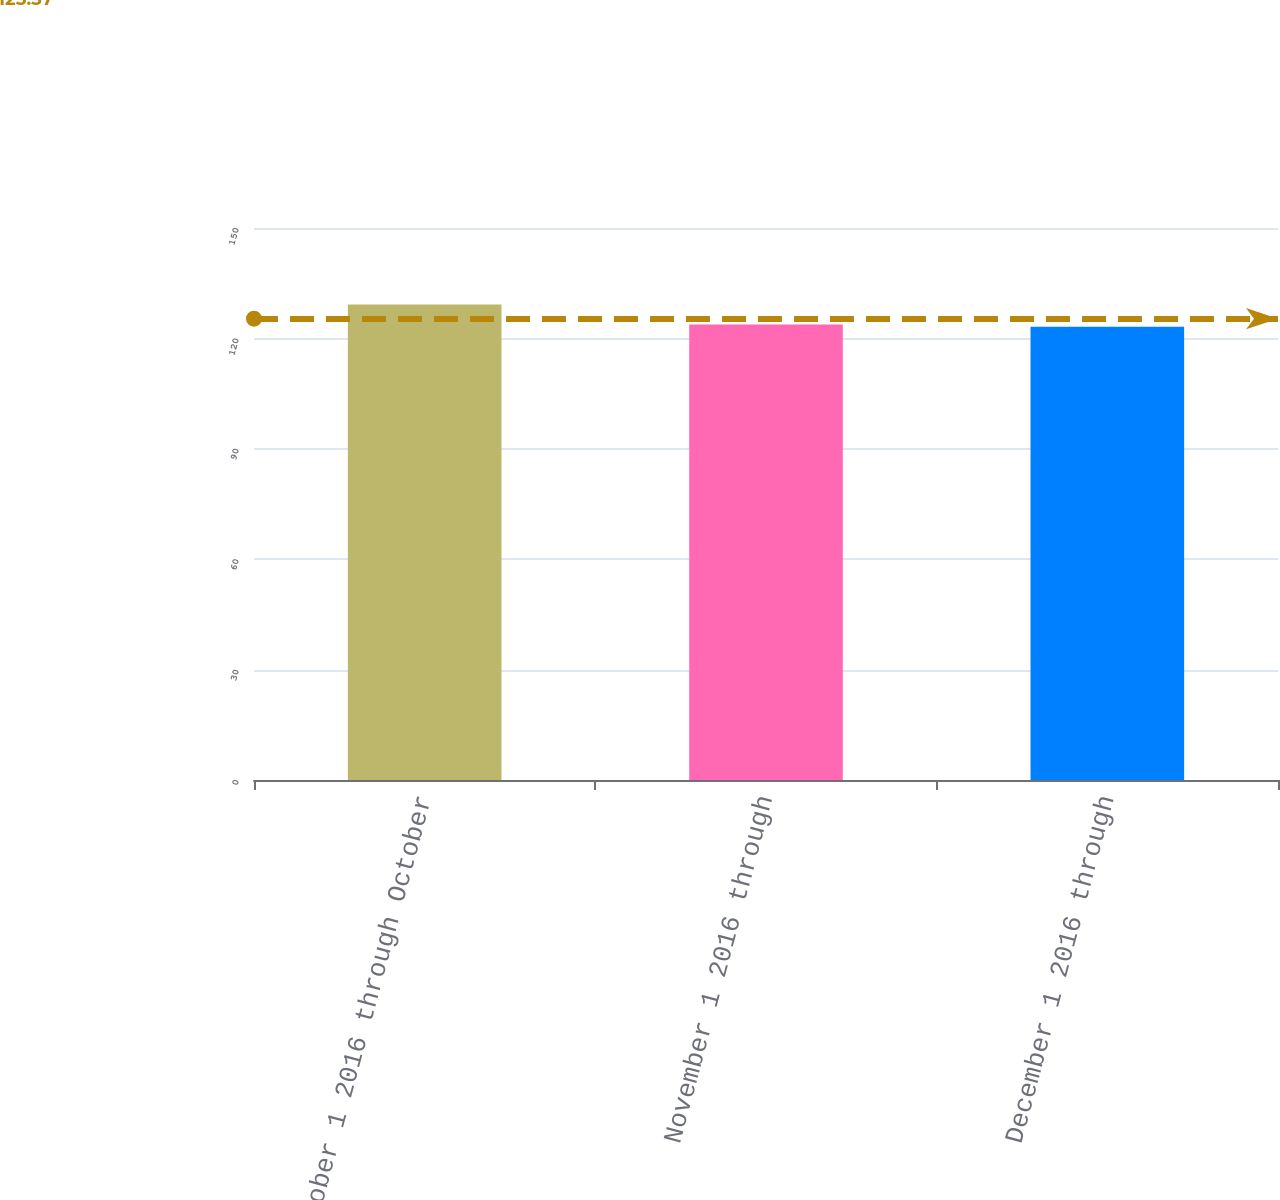Convert chart. <chart><loc_0><loc_0><loc_500><loc_500><bar_chart><fcel>October 1 2016 through October<fcel>November 1 2016 through<fcel>December 1 2016 through<nl><fcel>129.19<fcel>123.76<fcel>123.16<nl></chart> 